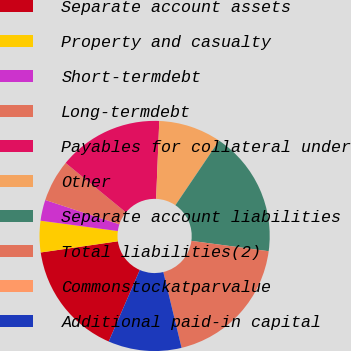Convert chart to OTSL. <chart><loc_0><loc_0><loc_500><loc_500><pie_chart><fcel>Separate account assets<fcel>Property and casualty<fcel>Short-termdebt<fcel>Long-termdebt<fcel>Payables for collateral under<fcel>Other<fcel>Separate account liabilities<fcel>Total liabilities(2)<fcel>Commonstockatparvalue<fcel>Additional paid-in capital<nl><fcel>16.18%<fcel>4.41%<fcel>2.94%<fcel>5.88%<fcel>14.71%<fcel>8.82%<fcel>17.65%<fcel>19.12%<fcel>0.0%<fcel>10.29%<nl></chart> 